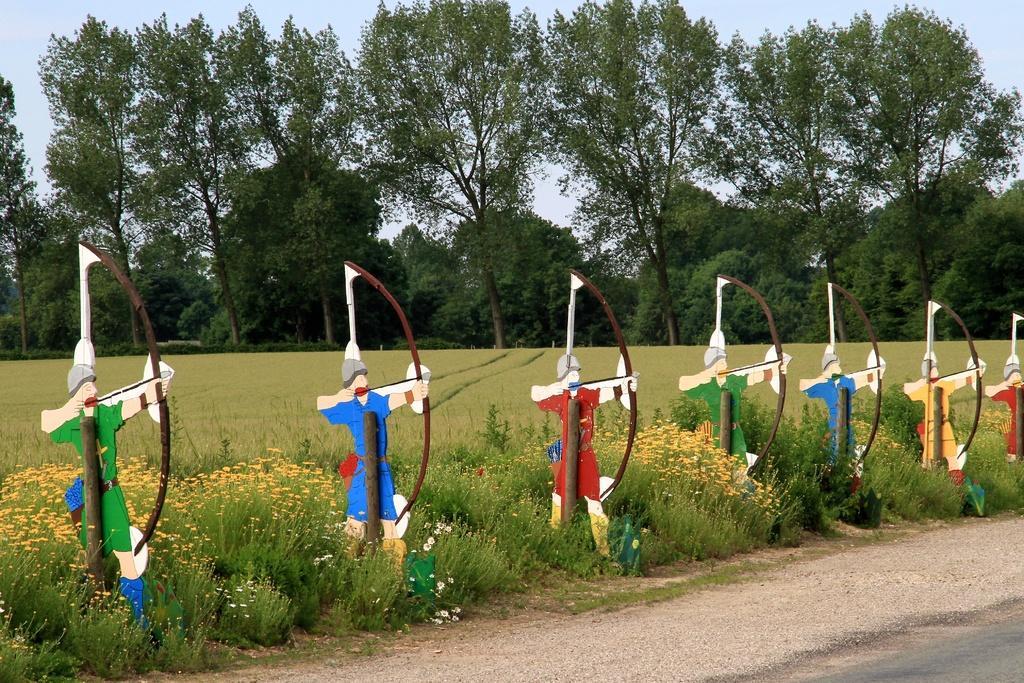Can you describe this image briefly? In this image I can see the boards to the poles. The boards which are in shape of the person. And these are in different colors. To the side I can see the plants with yellow color flowers. In the back there are many trees and the sky. 